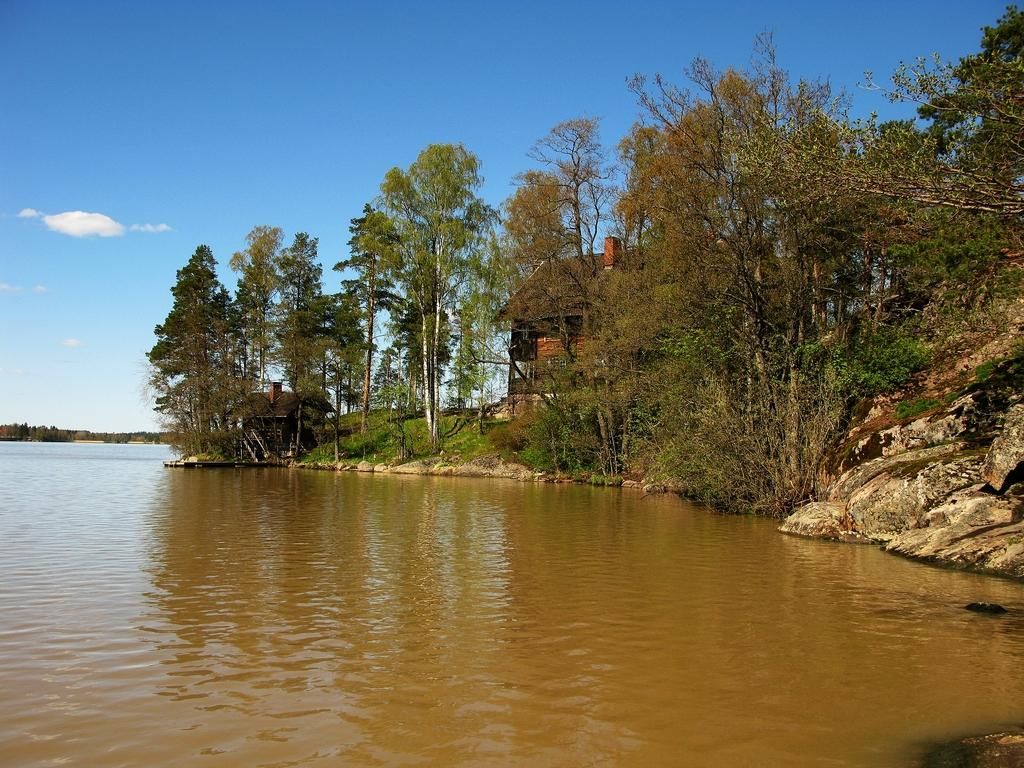What is the primary element visible in the image? There is water in the image. What can be seen in the distance behind the water? There are houses, trees, and rocks in the background of the image. What is visible at the top of the image? The sky is visible at the top of the image. How many pizzas are floating on the water in the image? There are no pizzas present in the image; it features water with a background of houses, trees, and rocks. Can you see any ducks swimming in the water in the image? There are no ducks visible in the image; it only shows water with a background of houses, trees, and rocks. 